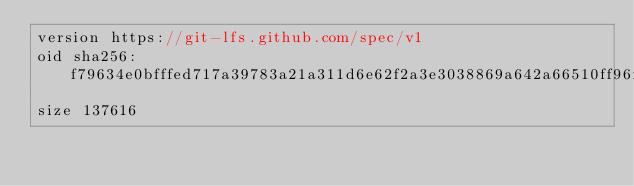<code> <loc_0><loc_0><loc_500><loc_500><_TypeScript_>version https://git-lfs.github.com/spec/v1
oid sha256:f79634e0bfffed717a39783a21a311d6e62f2a3e3038869a642a66510ff96fb7
size 137616
</code> 